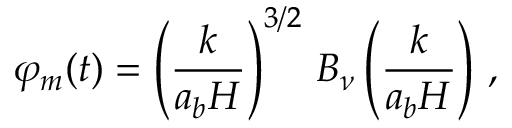<formula> <loc_0><loc_0><loc_500><loc_500>\varphi _ { m } ( t ) = \left ( \frac { k } { a _ { b } H } \right ) ^ { 3 / 2 } \, B _ { \nu } \left ( \frac { k } { a _ { b } H } \right ) \, ,</formula> 